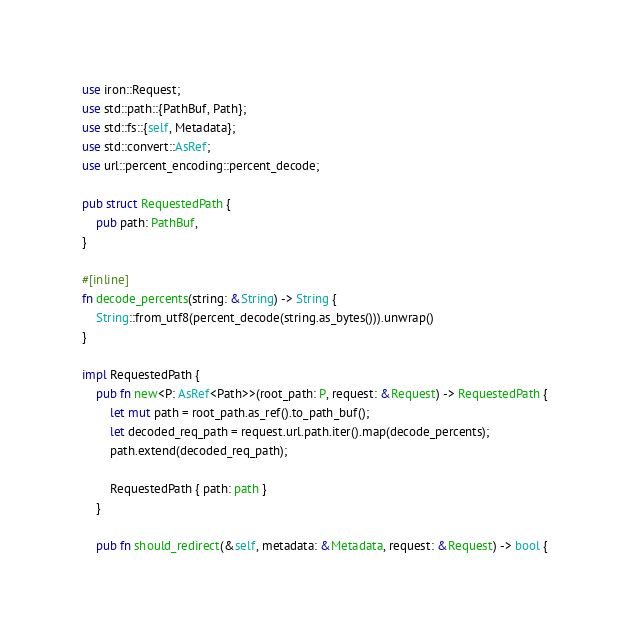<code> <loc_0><loc_0><loc_500><loc_500><_Rust_>use iron::Request;
use std::path::{PathBuf, Path};
use std::fs::{self, Metadata};
use std::convert::AsRef;
use url::percent_encoding::percent_decode;

pub struct RequestedPath {
    pub path: PathBuf,
}

#[inline]
fn decode_percents(string: &String) -> String {
    String::from_utf8(percent_decode(string.as_bytes())).unwrap()
}

impl RequestedPath {
    pub fn new<P: AsRef<Path>>(root_path: P, request: &Request) -> RequestedPath {
        let mut path = root_path.as_ref().to_path_buf();
        let decoded_req_path = request.url.path.iter().map(decode_percents);
        path.extend(decoded_req_path);

        RequestedPath { path: path }
    }

    pub fn should_redirect(&self, metadata: &Metadata, request: &Request) -> bool {</code> 